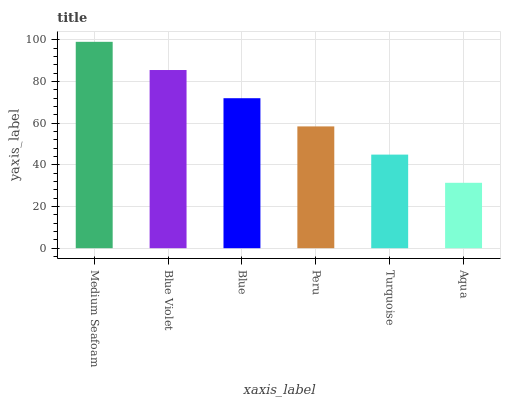Is Aqua the minimum?
Answer yes or no. Yes. Is Medium Seafoam the maximum?
Answer yes or no. Yes. Is Blue Violet the minimum?
Answer yes or no. No. Is Blue Violet the maximum?
Answer yes or no. No. Is Medium Seafoam greater than Blue Violet?
Answer yes or no. Yes. Is Blue Violet less than Medium Seafoam?
Answer yes or no. Yes. Is Blue Violet greater than Medium Seafoam?
Answer yes or no. No. Is Medium Seafoam less than Blue Violet?
Answer yes or no. No. Is Blue the high median?
Answer yes or no. Yes. Is Peru the low median?
Answer yes or no. Yes. Is Aqua the high median?
Answer yes or no. No. Is Aqua the low median?
Answer yes or no. No. 